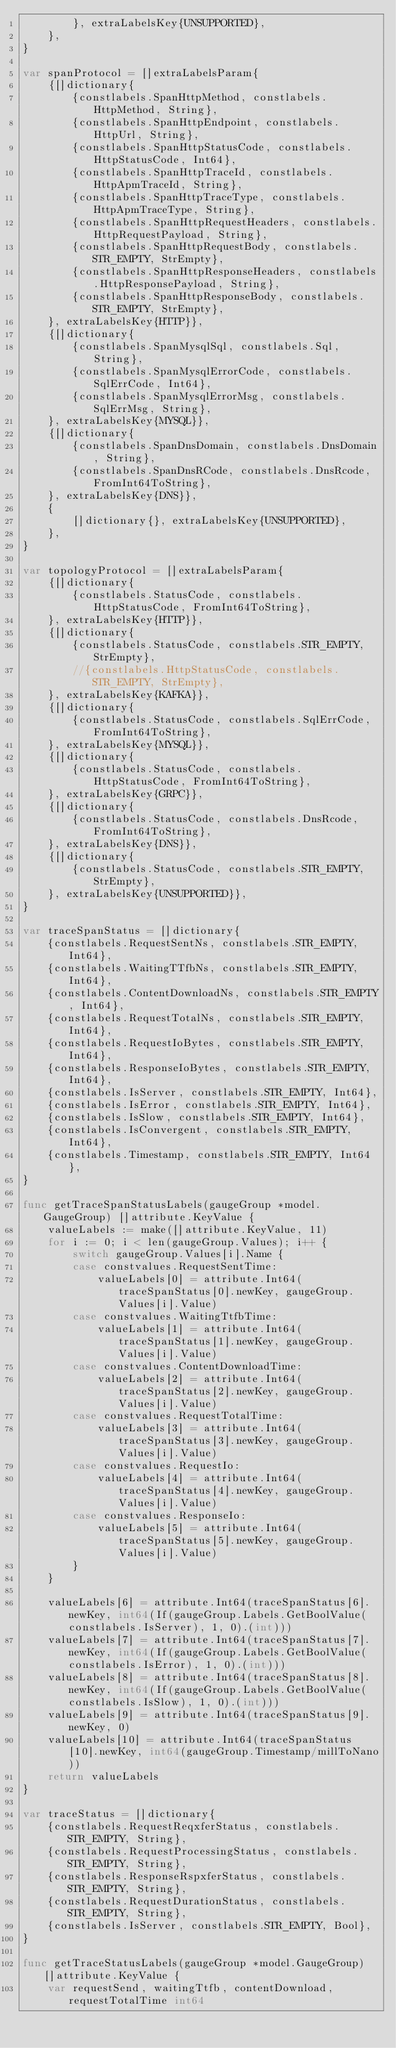Convert code to text. <code><loc_0><loc_0><loc_500><loc_500><_Go_>		}, extraLabelsKey{UNSUPPORTED},
	},
}

var spanProtocol = []extraLabelsParam{
	{[]dictionary{
		{constlabels.SpanHttpMethod, constlabels.HttpMethod, String},
		{constlabels.SpanHttpEndpoint, constlabels.HttpUrl, String},
		{constlabels.SpanHttpStatusCode, constlabels.HttpStatusCode, Int64},
		{constlabels.SpanHttpTraceId, constlabels.HttpApmTraceId, String},
		{constlabels.SpanHttpTraceType, constlabels.HttpApmTraceType, String},
		{constlabels.SpanHttpRequestHeaders, constlabels.HttpRequestPayload, String},
		{constlabels.SpanHttpRequestBody, constlabels.STR_EMPTY, StrEmpty},
		{constlabels.SpanHttpResponseHeaders, constlabels.HttpResponsePayload, String},
		{constlabels.SpanHttpResponseBody, constlabels.STR_EMPTY, StrEmpty},
	}, extraLabelsKey{HTTP}},
	{[]dictionary{
		{constlabels.SpanMysqlSql, constlabels.Sql, String},
		{constlabels.SpanMysqlErrorCode, constlabels.SqlErrCode, Int64},
		{constlabels.SpanMysqlErrorMsg, constlabels.SqlErrMsg, String},
	}, extraLabelsKey{MYSQL}},
	{[]dictionary{
		{constlabels.SpanDnsDomain, constlabels.DnsDomain, String},
		{constlabels.SpanDnsRCode, constlabels.DnsRcode, FromInt64ToString},
	}, extraLabelsKey{DNS}},
	{
		[]dictionary{}, extraLabelsKey{UNSUPPORTED},
	},
}

var topologyProtocol = []extraLabelsParam{
	{[]dictionary{
		{constlabels.StatusCode, constlabels.HttpStatusCode, FromInt64ToString},
	}, extraLabelsKey{HTTP}},
	{[]dictionary{
		{constlabels.StatusCode, constlabels.STR_EMPTY, StrEmpty},
		//{constlabels.HttpStatusCode, constlabels.STR_EMPTY, StrEmpty},
	}, extraLabelsKey{KAFKA}},
	{[]dictionary{
		{constlabels.StatusCode, constlabels.SqlErrCode, FromInt64ToString},
	}, extraLabelsKey{MYSQL}},
	{[]dictionary{
		{constlabels.StatusCode, constlabels.HttpStatusCode, FromInt64ToString},
	}, extraLabelsKey{GRPC}},
	{[]dictionary{
		{constlabels.StatusCode, constlabels.DnsRcode, FromInt64ToString},
	}, extraLabelsKey{DNS}},
	{[]dictionary{
		{constlabels.StatusCode, constlabels.STR_EMPTY, StrEmpty},
	}, extraLabelsKey{UNSUPPORTED}},
}

var traceSpanStatus = []dictionary{
	{constlabels.RequestSentNs, constlabels.STR_EMPTY, Int64},
	{constlabels.WaitingTTfbNs, constlabels.STR_EMPTY, Int64},
	{constlabels.ContentDownloadNs, constlabels.STR_EMPTY, Int64},
	{constlabels.RequestTotalNs, constlabels.STR_EMPTY, Int64},
	{constlabels.RequestIoBytes, constlabels.STR_EMPTY, Int64},
	{constlabels.ResponseIoBytes, constlabels.STR_EMPTY, Int64},
	{constlabels.IsServer, constlabels.STR_EMPTY, Int64},
	{constlabels.IsError, constlabels.STR_EMPTY, Int64},
	{constlabels.IsSlow, constlabels.STR_EMPTY, Int64},
	{constlabels.IsConvergent, constlabels.STR_EMPTY, Int64},
	{constlabels.Timestamp, constlabels.STR_EMPTY, Int64},
}

func getTraceSpanStatusLabels(gaugeGroup *model.GaugeGroup) []attribute.KeyValue {
	valueLabels := make([]attribute.KeyValue, 11)
	for i := 0; i < len(gaugeGroup.Values); i++ {
		switch gaugeGroup.Values[i].Name {
		case constvalues.RequestSentTime:
			valueLabels[0] = attribute.Int64(traceSpanStatus[0].newKey, gaugeGroup.Values[i].Value)
		case constvalues.WaitingTtfbTime:
			valueLabels[1] = attribute.Int64(traceSpanStatus[1].newKey, gaugeGroup.Values[i].Value)
		case constvalues.ContentDownloadTime:
			valueLabels[2] = attribute.Int64(traceSpanStatus[2].newKey, gaugeGroup.Values[i].Value)
		case constvalues.RequestTotalTime:
			valueLabels[3] = attribute.Int64(traceSpanStatus[3].newKey, gaugeGroup.Values[i].Value)
		case constvalues.RequestIo:
			valueLabels[4] = attribute.Int64(traceSpanStatus[4].newKey, gaugeGroup.Values[i].Value)
		case constvalues.ResponseIo:
			valueLabels[5] = attribute.Int64(traceSpanStatus[5].newKey, gaugeGroup.Values[i].Value)
		}
	}

	valueLabels[6] = attribute.Int64(traceSpanStatus[6].newKey, int64(If(gaugeGroup.Labels.GetBoolValue(constlabels.IsServer), 1, 0).(int)))
	valueLabels[7] = attribute.Int64(traceSpanStatus[7].newKey, int64(If(gaugeGroup.Labels.GetBoolValue(constlabels.IsError), 1, 0).(int)))
	valueLabels[8] = attribute.Int64(traceSpanStatus[8].newKey, int64(If(gaugeGroup.Labels.GetBoolValue(constlabels.IsSlow), 1, 0).(int)))
	valueLabels[9] = attribute.Int64(traceSpanStatus[9].newKey, 0)
	valueLabels[10] = attribute.Int64(traceSpanStatus[10].newKey, int64(gaugeGroup.Timestamp/millToNano))
	return valueLabels
}

var traceStatus = []dictionary{
	{constlabels.RequestReqxferStatus, constlabels.STR_EMPTY, String},
	{constlabels.RequestProcessingStatus, constlabels.STR_EMPTY, String},
	{constlabels.ResponseRspxferStatus, constlabels.STR_EMPTY, String},
	{constlabels.RequestDurationStatus, constlabels.STR_EMPTY, String},
	{constlabels.IsServer, constlabels.STR_EMPTY, Bool},
}

func getTraceStatusLabels(gaugeGroup *model.GaugeGroup) []attribute.KeyValue {
	var requestSend, waitingTtfb, contentDownload, requestTotalTime int64</code> 